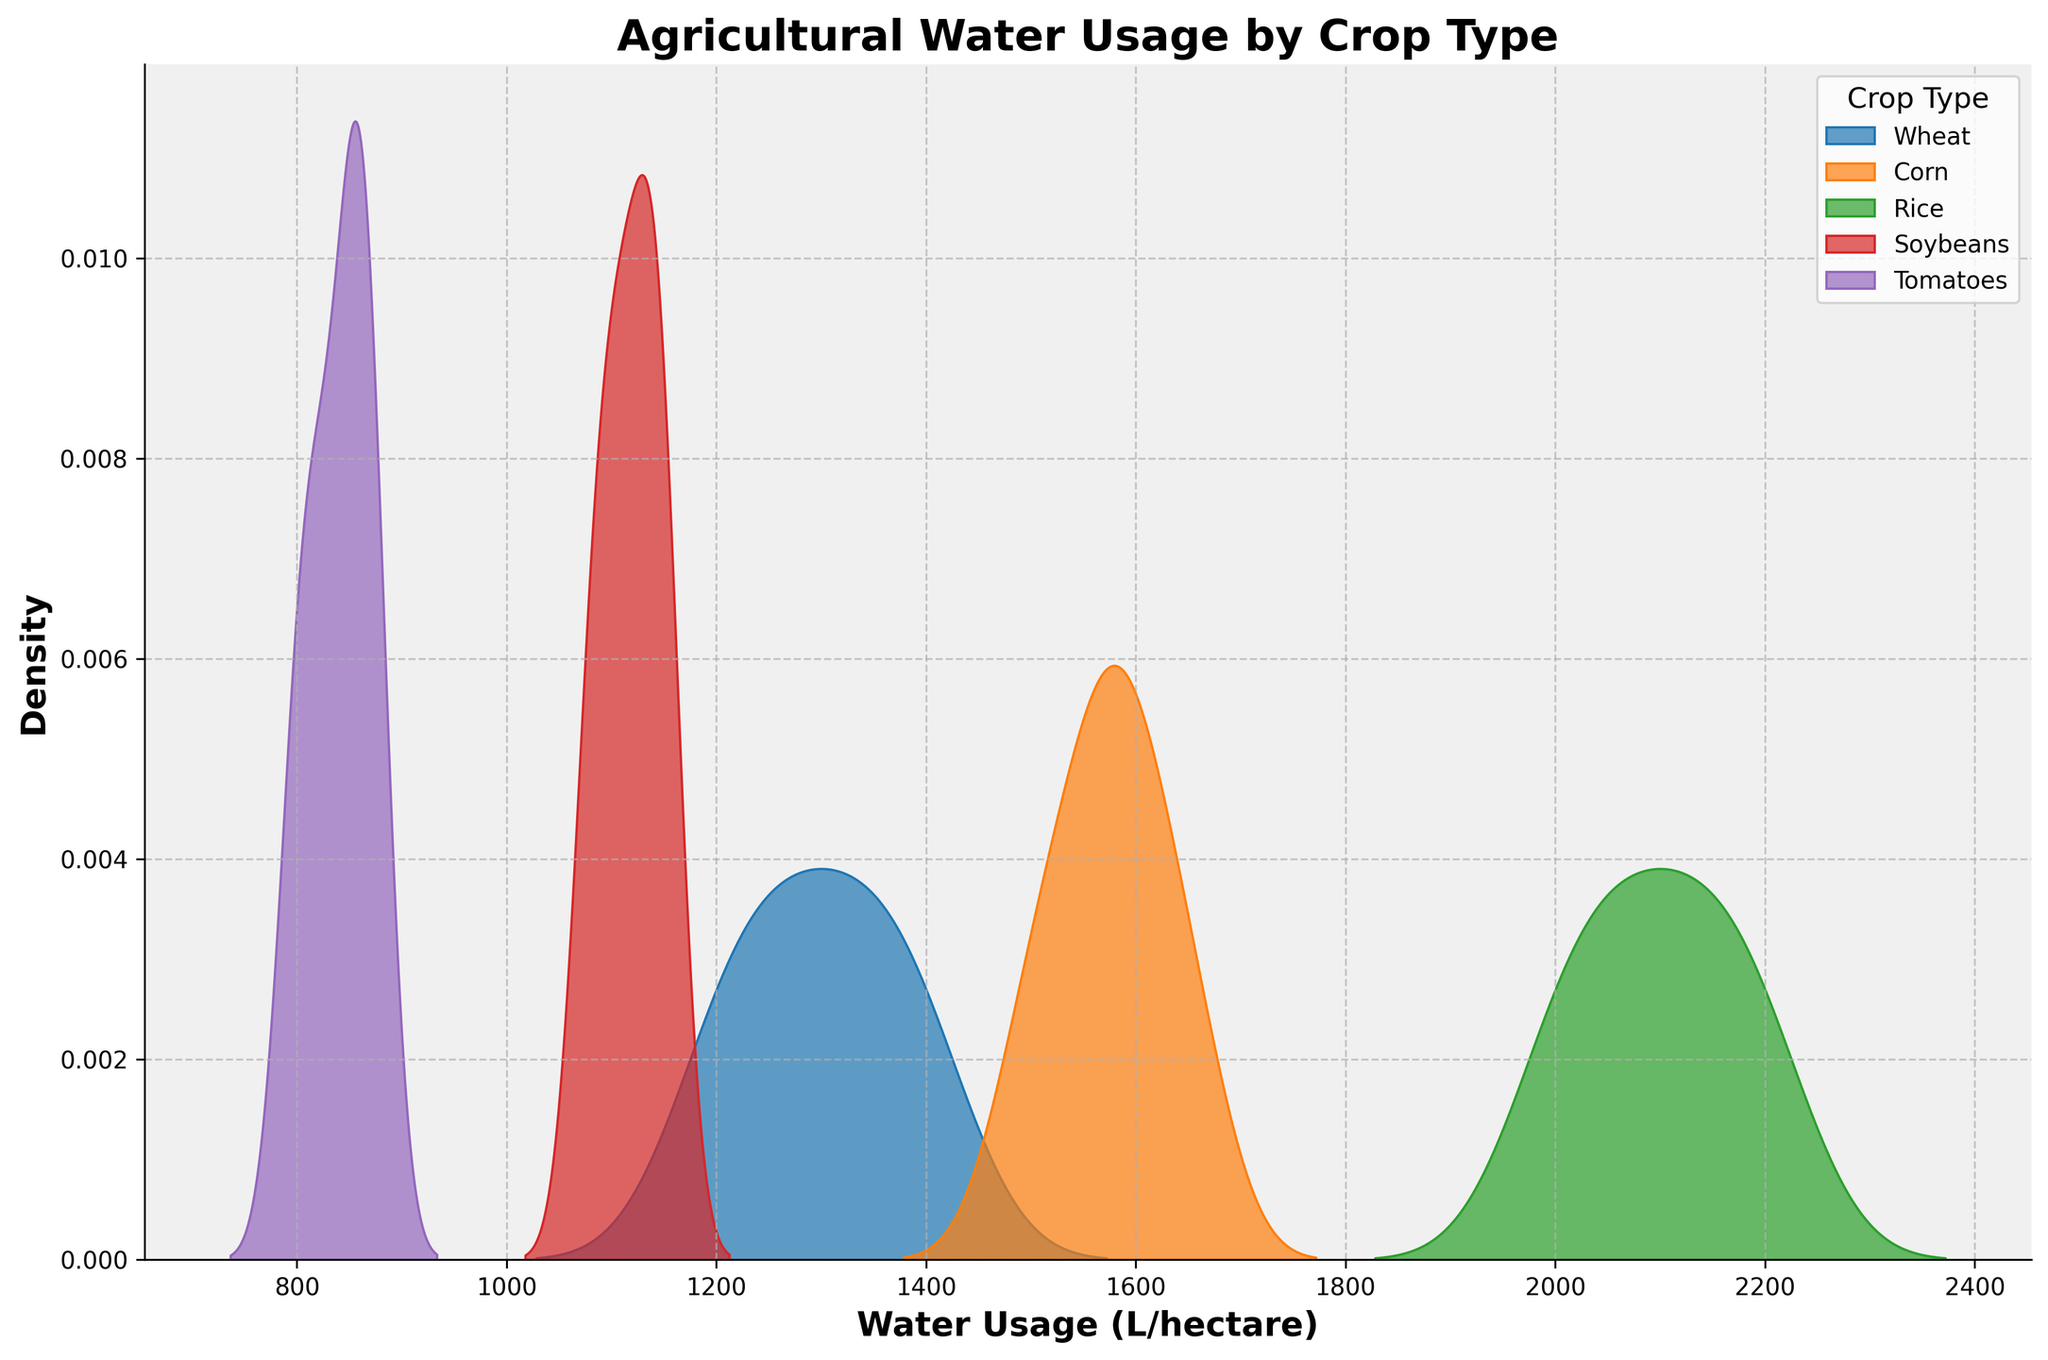What is the title of the figure? The title is displayed prominently at the top of the figure. It is usually the first piece of text you read when looking at a plot. The title helps in understanding the context of the data being presented.
Answer: Agricultural Water Usage by Crop Type What are the labels on the x-axis and y-axis? The labels on the axes define what data is represented by each axis. The x-axis label is provided below the horizontal axis, and the y-axis label is given to the left of the vertical axis.
Answer: Water Usage (L/hectare), Density Which crop type has the highest peak in water usage density? Density peaks indicate the most common water usage values for each crop type. The crop with the highest peak is the one with the most common water usage across its range.
Answer: Rice Which crop requires the least amount of water according to the density plot? To find the crop with the least water usage, look for the distribution that starts at the lowest water usage values on the x-axis.
Answer: Tomatoes Which crop has the largest spread in water usage? The largest spread can be observed by examining the width of the density distribution on the x-axis. A wider distribution indicates a larger spread.
Answer: Corn Between Wheat and Soybeans, which crop type exhibits lower average water usage? To compare average water usage, you can look at the peak locations of each density plot. The peak closer to the left indicates a lower average water usage. Wheat’s density plot peaks around 1300 L/hectare, while Soybeans peak around 1100 L/hectare.
Answer: Soybeans What is the range of water usage for Corn? The range of water usage is determined by the extent of the density plot along the x-axis. For Corn, the density plot extends approximately from 1500 L/hectare to 1650 L/hectare.
Answer: 1500-1650 L/hectare Is there a crop that uses water similarly to another crop? Crops using similar amounts of water will have density plots that overlap significantly on the x-axis.
Answer: Wheat and Corn Between Rice and Tomatoes, which has a narrower peak indicating higher consistency in water usage? A narrower peak suggests that the water usage values are more consistent (less variability). Rice, having a narrower peak than Tomatoes, indicates more consistent water usage.
Answer: Rice What can you infer about the water usage of Soybeans from its density plot shape? The shape of the density plot for Soybeans, which is relatively narrow and peaks sharply, indicates that most of the water usage values are closely clustered around its peak, suggesting low variability in water usage.
Answer: Low variability in water usage 